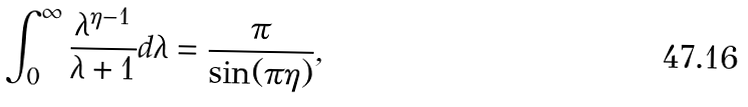<formula> <loc_0><loc_0><loc_500><loc_500>\int _ { 0 } ^ { \infty } \frac { \lambda ^ { \eta - 1 } } { \lambda + 1 } d \lambda = \frac { \pi } { \sin ( \pi \eta ) } ,</formula> 